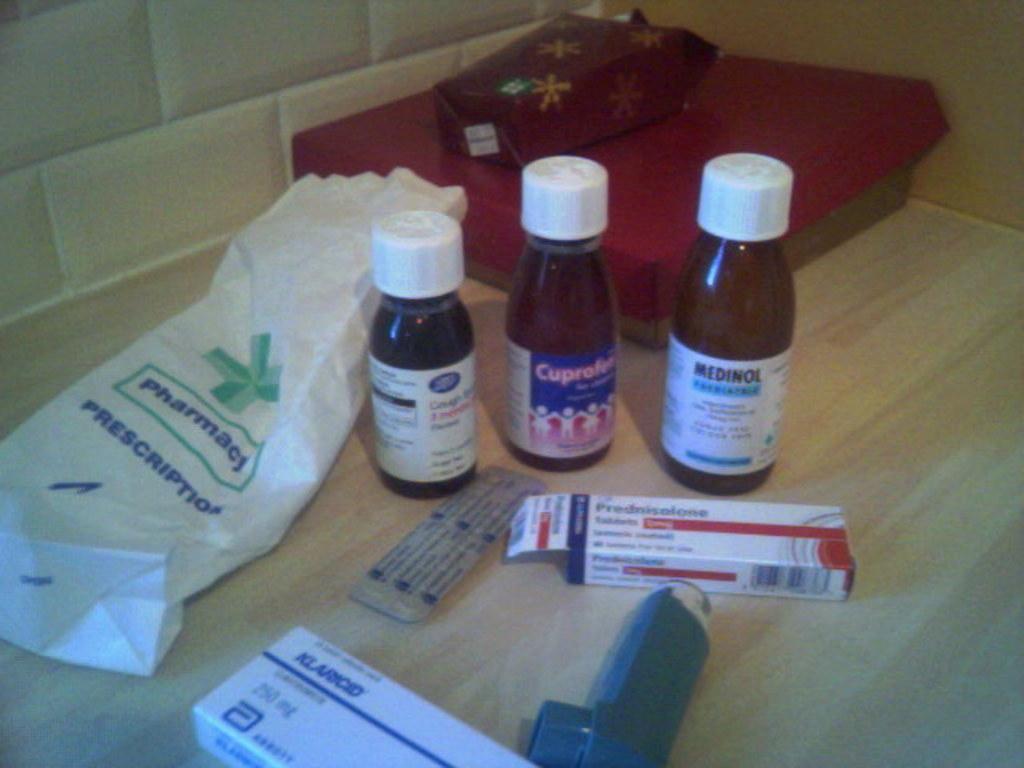Where did the medications come from?
Give a very brief answer. Pharmacy. What is printed on the bottle in middle?
Your answer should be compact. Cuprofen. 